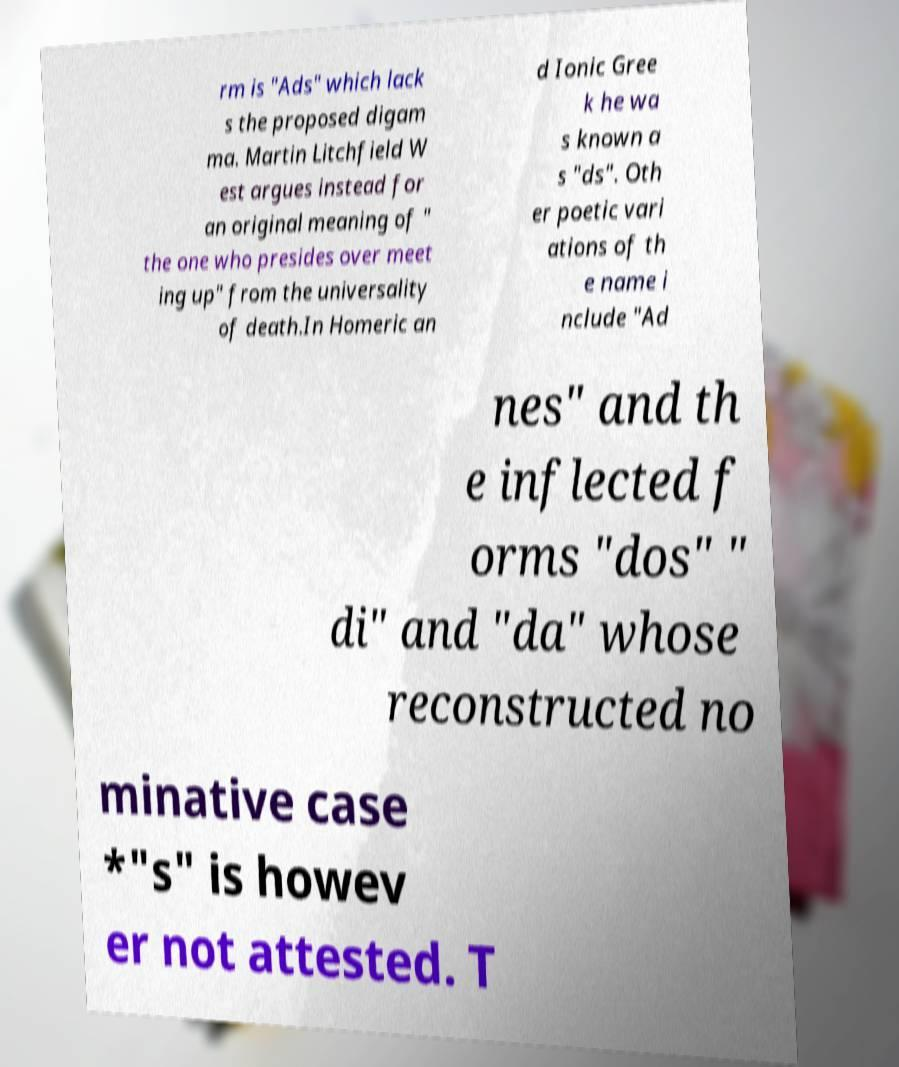There's text embedded in this image that I need extracted. Can you transcribe it verbatim? rm is "Ads" which lack s the proposed digam ma. Martin Litchfield W est argues instead for an original meaning of " the one who presides over meet ing up" from the universality of death.In Homeric an d Ionic Gree k he wa s known a s "ds". Oth er poetic vari ations of th e name i nclude "Ad nes" and th e inflected f orms "dos" " di" and "da" whose reconstructed no minative case *"s" is howev er not attested. T 